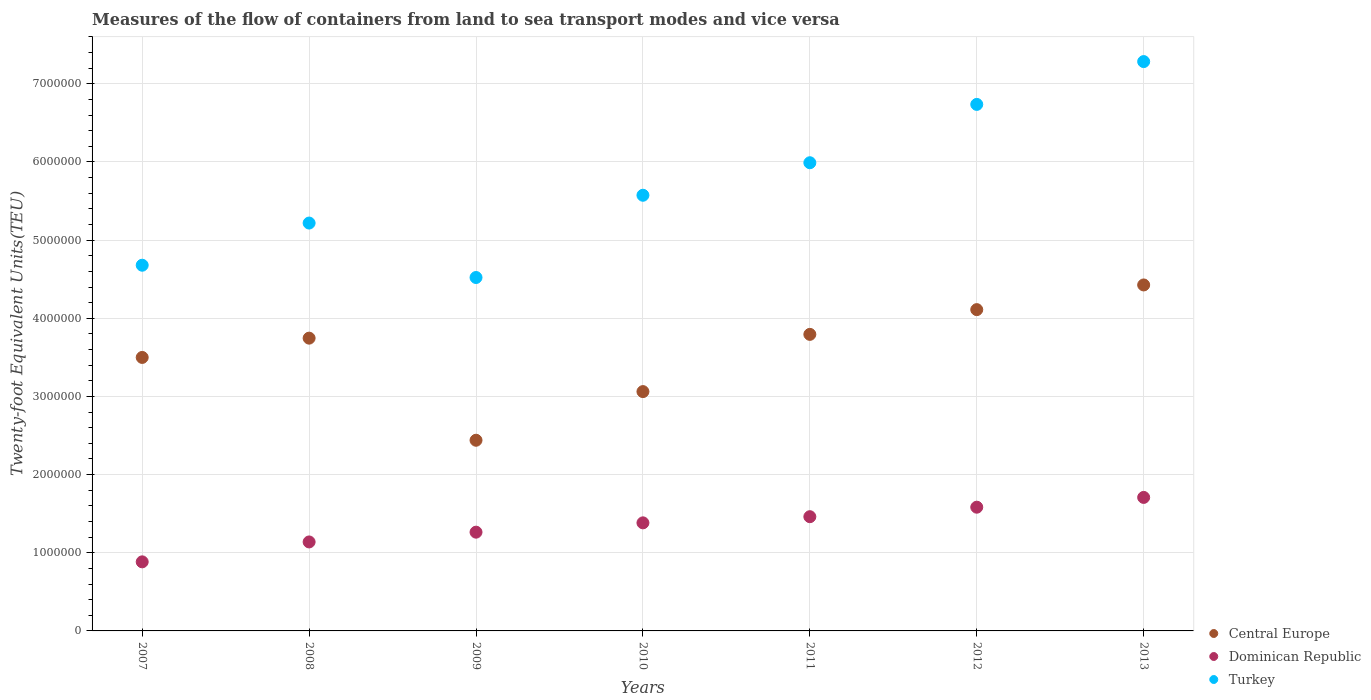How many different coloured dotlines are there?
Ensure brevity in your answer.  3. What is the container port traffic in Turkey in 2009?
Your answer should be very brief. 4.52e+06. Across all years, what is the maximum container port traffic in Dominican Republic?
Your response must be concise. 1.71e+06. Across all years, what is the minimum container port traffic in Turkey?
Ensure brevity in your answer.  4.52e+06. In which year was the container port traffic in Turkey maximum?
Your response must be concise. 2013. In which year was the container port traffic in Turkey minimum?
Your response must be concise. 2009. What is the total container port traffic in Central Europe in the graph?
Make the answer very short. 2.51e+07. What is the difference between the container port traffic in Dominican Republic in 2011 and that in 2012?
Make the answer very short. -1.22e+05. What is the difference between the container port traffic in Central Europe in 2011 and the container port traffic in Dominican Republic in 2008?
Your response must be concise. 2.66e+06. What is the average container port traffic in Central Europe per year?
Provide a succinct answer. 3.58e+06. In the year 2010, what is the difference between the container port traffic in Dominican Republic and container port traffic in Turkey?
Your answer should be very brief. -4.19e+06. In how many years, is the container port traffic in Dominican Republic greater than 1200000 TEU?
Your answer should be compact. 5. What is the ratio of the container port traffic in Turkey in 2011 to that in 2012?
Make the answer very short. 0.89. Is the difference between the container port traffic in Dominican Republic in 2011 and 2013 greater than the difference between the container port traffic in Turkey in 2011 and 2013?
Offer a terse response. Yes. What is the difference between the highest and the second highest container port traffic in Turkey?
Ensure brevity in your answer.  5.48e+05. What is the difference between the highest and the lowest container port traffic in Turkey?
Provide a succinct answer. 2.76e+06. In how many years, is the container port traffic in Dominican Republic greater than the average container port traffic in Dominican Republic taken over all years?
Your answer should be very brief. 4. Is the sum of the container port traffic in Central Europe in 2007 and 2013 greater than the maximum container port traffic in Turkey across all years?
Make the answer very short. Yes. Is it the case that in every year, the sum of the container port traffic in Turkey and container port traffic in Central Europe  is greater than the container port traffic in Dominican Republic?
Your answer should be very brief. Yes. Is the container port traffic in Dominican Republic strictly greater than the container port traffic in Turkey over the years?
Provide a succinct answer. No. Is the container port traffic in Central Europe strictly less than the container port traffic in Turkey over the years?
Provide a short and direct response. Yes. How many dotlines are there?
Make the answer very short. 3. How many years are there in the graph?
Give a very brief answer. 7. Does the graph contain any zero values?
Keep it short and to the point. No. Where does the legend appear in the graph?
Provide a short and direct response. Bottom right. How many legend labels are there?
Your response must be concise. 3. What is the title of the graph?
Offer a very short reply. Measures of the flow of containers from land to sea transport modes and vice versa. What is the label or title of the X-axis?
Offer a terse response. Years. What is the label or title of the Y-axis?
Provide a short and direct response. Twenty-foot Equivalent Units(TEU). What is the Twenty-foot Equivalent Units(TEU) in Central Europe in 2007?
Provide a short and direct response. 3.50e+06. What is the Twenty-foot Equivalent Units(TEU) in Dominican Republic in 2007?
Offer a very short reply. 8.84e+05. What is the Twenty-foot Equivalent Units(TEU) of Turkey in 2007?
Ensure brevity in your answer.  4.68e+06. What is the Twenty-foot Equivalent Units(TEU) in Central Europe in 2008?
Offer a terse response. 3.75e+06. What is the Twenty-foot Equivalent Units(TEU) of Dominican Republic in 2008?
Your answer should be very brief. 1.14e+06. What is the Twenty-foot Equivalent Units(TEU) in Turkey in 2008?
Your response must be concise. 5.22e+06. What is the Twenty-foot Equivalent Units(TEU) in Central Europe in 2009?
Provide a short and direct response. 2.44e+06. What is the Twenty-foot Equivalent Units(TEU) in Dominican Republic in 2009?
Give a very brief answer. 1.26e+06. What is the Twenty-foot Equivalent Units(TEU) of Turkey in 2009?
Offer a very short reply. 4.52e+06. What is the Twenty-foot Equivalent Units(TEU) in Central Europe in 2010?
Keep it short and to the point. 3.06e+06. What is the Twenty-foot Equivalent Units(TEU) in Dominican Republic in 2010?
Provide a succinct answer. 1.38e+06. What is the Twenty-foot Equivalent Units(TEU) in Turkey in 2010?
Make the answer very short. 5.57e+06. What is the Twenty-foot Equivalent Units(TEU) in Central Europe in 2011?
Your answer should be very brief. 3.79e+06. What is the Twenty-foot Equivalent Units(TEU) of Dominican Republic in 2011?
Keep it short and to the point. 1.46e+06. What is the Twenty-foot Equivalent Units(TEU) of Turkey in 2011?
Your answer should be compact. 5.99e+06. What is the Twenty-foot Equivalent Units(TEU) in Central Europe in 2012?
Provide a short and direct response. 4.11e+06. What is the Twenty-foot Equivalent Units(TEU) of Dominican Republic in 2012?
Your answer should be very brief. 1.58e+06. What is the Twenty-foot Equivalent Units(TEU) in Turkey in 2012?
Your answer should be very brief. 6.74e+06. What is the Twenty-foot Equivalent Units(TEU) in Central Europe in 2013?
Your response must be concise. 4.43e+06. What is the Twenty-foot Equivalent Units(TEU) in Dominican Republic in 2013?
Ensure brevity in your answer.  1.71e+06. What is the Twenty-foot Equivalent Units(TEU) in Turkey in 2013?
Provide a short and direct response. 7.28e+06. Across all years, what is the maximum Twenty-foot Equivalent Units(TEU) in Central Europe?
Ensure brevity in your answer.  4.43e+06. Across all years, what is the maximum Twenty-foot Equivalent Units(TEU) in Dominican Republic?
Your answer should be very brief. 1.71e+06. Across all years, what is the maximum Twenty-foot Equivalent Units(TEU) in Turkey?
Offer a terse response. 7.28e+06. Across all years, what is the minimum Twenty-foot Equivalent Units(TEU) of Central Europe?
Your answer should be very brief. 2.44e+06. Across all years, what is the minimum Twenty-foot Equivalent Units(TEU) in Dominican Republic?
Provide a short and direct response. 8.84e+05. Across all years, what is the minimum Twenty-foot Equivalent Units(TEU) in Turkey?
Provide a short and direct response. 4.52e+06. What is the total Twenty-foot Equivalent Units(TEU) of Central Europe in the graph?
Ensure brevity in your answer.  2.51e+07. What is the total Twenty-foot Equivalent Units(TEU) in Dominican Republic in the graph?
Offer a terse response. 9.42e+06. What is the total Twenty-foot Equivalent Units(TEU) of Turkey in the graph?
Provide a short and direct response. 4.00e+07. What is the difference between the Twenty-foot Equivalent Units(TEU) of Central Europe in 2007 and that in 2008?
Your answer should be compact. -2.47e+05. What is the difference between the Twenty-foot Equivalent Units(TEU) of Dominican Republic in 2007 and that in 2008?
Offer a very short reply. -2.55e+05. What is the difference between the Twenty-foot Equivalent Units(TEU) of Turkey in 2007 and that in 2008?
Offer a terse response. -5.39e+05. What is the difference between the Twenty-foot Equivalent Units(TEU) of Central Europe in 2007 and that in 2009?
Offer a very short reply. 1.06e+06. What is the difference between the Twenty-foot Equivalent Units(TEU) in Dominican Republic in 2007 and that in 2009?
Provide a succinct answer. -3.80e+05. What is the difference between the Twenty-foot Equivalent Units(TEU) in Turkey in 2007 and that in 2009?
Provide a short and direct response. 1.57e+05. What is the difference between the Twenty-foot Equivalent Units(TEU) in Central Europe in 2007 and that in 2010?
Provide a short and direct response. 4.37e+05. What is the difference between the Twenty-foot Equivalent Units(TEU) in Dominican Republic in 2007 and that in 2010?
Your response must be concise. -4.99e+05. What is the difference between the Twenty-foot Equivalent Units(TEU) of Turkey in 2007 and that in 2010?
Your response must be concise. -8.95e+05. What is the difference between the Twenty-foot Equivalent Units(TEU) in Central Europe in 2007 and that in 2011?
Give a very brief answer. -2.95e+05. What is the difference between the Twenty-foot Equivalent Units(TEU) of Dominican Republic in 2007 and that in 2011?
Give a very brief answer. -5.78e+05. What is the difference between the Twenty-foot Equivalent Units(TEU) of Turkey in 2007 and that in 2011?
Provide a succinct answer. -1.31e+06. What is the difference between the Twenty-foot Equivalent Units(TEU) in Central Europe in 2007 and that in 2012?
Provide a succinct answer. -6.12e+05. What is the difference between the Twenty-foot Equivalent Units(TEU) in Dominican Republic in 2007 and that in 2012?
Provide a short and direct response. -6.99e+05. What is the difference between the Twenty-foot Equivalent Units(TEU) in Turkey in 2007 and that in 2012?
Ensure brevity in your answer.  -2.06e+06. What is the difference between the Twenty-foot Equivalent Units(TEU) of Central Europe in 2007 and that in 2013?
Give a very brief answer. -9.27e+05. What is the difference between the Twenty-foot Equivalent Units(TEU) of Dominican Republic in 2007 and that in 2013?
Offer a terse response. -8.24e+05. What is the difference between the Twenty-foot Equivalent Units(TEU) in Turkey in 2007 and that in 2013?
Make the answer very short. -2.61e+06. What is the difference between the Twenty-foot Equivalent Units(TEU) in Central Europe in 2008 and that in 2009?
Your answer should be very brief. 1.31e+06. What is the difference between the Twenty-foot Equivalent Units(TEU) in Dominican Republic in 2008 and that in 2009?
Keep it short and to the point. -1.25e+05. What is the difference between the Twenty-foot Equivalent Units(TEU) in Turkey in 2008 and that in 2009?
Offer a very short reply. 6.97e+05. What is the difference between the Twenty-foot Equivalent Units(TEU) of Central Europe in 2008 and that in 2010?
Your answer should be compact. 6.84e+05. What is the difference between the Twenty-foot Equivalent Units(TEU) in Dominican Republic in 2008 and that in 2010?
Provide a succinct answer. -2.44e+05. What is the difference between the Twenty-foot Equivalent Units(TEU) in Turkey in 2008 and that in 2010?
Provide a succinct answer. -3.56e+05. What is the difference between the Twenty-foot Equivalent Units(TEU) of Central Europe in 2008 and that in 2011?
Give a very brief answer. -4.83e+04. What is the difference between the Twenty-foot Equivalent Units(TEU) of Dominican Republic in 2008 and that in 2011?
Offer a very short reply. -3.23e+05. What is the difference between the Twenty-foot Equivalent Units(TEU) of Turkey in 2008 and that in 2011?
Offer a terse response. -7.72e+05. What is the difference between the Twenty-foot Equivalent Units(TEU) in Central Europe in 2008 and that in 2012?
Your answer should be compact. -3.65e+05. What is the difference between the Twenty-foot Equivalent Units(TEU) in Dominican Republic in 2008 and that in 2012?
Give a very brief answer. -4.45e+05. What is the difference between the Twenty-foot Equivalent Units(TEU) in Turkey in 2008 and that in 2012?
Your answer should be compact. -1.52e+06. What is the difference between the Twenty-foot Equivalent Units(TEU) in Central Europe in 2008 and that in 2013?
Ensure brevity in your answer.  -6.81e+05. What is the difference between the Twenty-foot Equivalent Units(TEU) in Dominican Republic in 2008 and that in 2013?
Your answer should be very brief. -5.70e+05. What is the difference between the Twenty-foot Equivalent Units(TEU) of Turkey in 2008 and that in 2013?
Give a very brief answer. -2.07e+06. What is the difference between the Twenty-foot Equivalent Units(TEU) of Central Europe in 2009 and that in 2010?
Give a very brief answer. -6.22e+05. What is the difference between the Twenty-foot Equivalent Units(TEU) in Dominican Republic in 2009 and that in 2010?
Your answer should be very brief. -1.19e+05. What is the difference between the Twenty-foot Equivalent Units(TEU) of Turkey in 2009 and that in 2010?
Your answer should be compact. -1.05e+06. What is the difference between the Twenty-foot Equivalent Units(TEU) of Central Europe in 2009 and that in 2011?
Make the answer very short. -1.35e+06. What is the difference between the Twenty-foot Equivalent Units(TEU) of Dominican Republic in 2009 and that in 2011?
Provide a succinct answer. -1.98e+05. What is the difference between the Twenty-foot Equivalent Units(TEU) in Turkey in 2009 and that in 2011?
Offer a very short reply. -1.47e+06. What is the difference between the Twenty-foot Equivalent Units(TEU) in Central Europe in 2009 and that in 2012?
Your answer should be compact. -1.67e+06. What is the difference between the Twenty-foot Equivalent Units(TEU) of Dominican Republic in 2009 and that in 2012?
Offer a terse response. -3.20e+05. What is the difference between the Twenty-foot Equivalent Units(TEU) in Turkey in 2009 and that in 2012?
Your answer should be compact. -2.21e+06. What is the difference between the Twenty-foot Equivalent Units(TEU) of Central Europe in 2009 and that in 2013?
Provide a succinct answer. -1.99e+06. What is the difference between the Twenty-foot Equivalent Units(TEU) in Dominican Republic in 2009 and that in 2013?
Give a very brief answer. -4.45e+05. What is the difference between the Twenty-foot Equivalent Units(TEU) of Turkey in 2009 and that in 2013?
Give a very brief answer. -2.76e+06. What is the difference between the Twenty-foot Equivalent Units(TEU) of Central Europe in 2010 and that in 2011?
Give a very brief answer. -7.32e+05. What is the difference between the Twenty-foot Equivalent Units(TEU) in Dominican Republic in 2010 and that in 2011?
Ensure brevity in your answer.  -7.88e+04. What is the difference between the Twenty-foot Equivalent Units(TEU) of Turkey in 2010 and that in 2011?
Provide a succinct answer. -4.16e+05. What is the difference between the Twenty-foot Equivalent Units(TEU) of Central Europe in 2010 and that in 2012?
Your answer should be compact. -1.05e+06. What is the difference between the Twenty-foot Equivalent Units(TEU) in Dominican Republic in 2010 and that in 2012?
Your answer should be compact. -2.00e+05. What is the difference between the Twenty-foot Equivalent Units(TEU) of Turkey in 2010 and that in 2012?
Make the answer very short. -1.16e+06. What is the difference between the Twenty-foot Equivalent Units(TEU) of Central Europe in 2010 and that in 2013?
Your answer should be very brief. -1.36e+06. What is the difference between the Twenty-foot Equivalent Units(TEU) of Dominican Republic in 2010 and that in 2013?
Offer a very short reply. -3.25e+05. What is the difference between the Twenty-foot Equivalent Units(TEU) of Turkey in 2010 and that in 2013?
Give a very brief answer. -1.71e+06. What is the difference between the Twenty-foot Equivalent Units(TEU) of Central Europe in 2011 and that in 2012?
Ensure brevity in your answer.  -3.17e+05. What is the difference between the Twenty-foot Equivalent Units(TEU) in Dominican Republic in 2011 and that in 2012?
Provide a succinct answer. -1.22e+05. What is the difference between the Twenty-foot Equivalent Units(TEU) of Turkey in 2011 and that in 2012?
Provide a short and direct response. -7.46e+05. What is the difference between the Twenty-foot Equivalent Units(TEU) in Central Europe in 2011 and that in 2013?
Your answer should be very brief. -6.32e+05. What is the difference between the Twenty-foot Equivalent Units(TEU) of Dominican Republic in 2011 and that in 2013?
Your answer should be very brief. -2.47e+05. What is the difference between the Twenty-foot Equivalent Units(TEU) of Turkey in 2011 and that in 2013?
Make the answer very short. -1.29e+06. What is the difference between the Twenty-foot Equivalent Units(TEU) of Central Europe in 2012 and that in 2013?
Provide a succinct answer. -3.16e+05. What is the difference between the Twenty-foot Equivalent Units(TEU) in Dominican Republic in 2012 and that in 2013?
Your response must be concise. -1.25e+05. What is the difference between the Twenty-foot Equivalent Units(TEU) of Turkey in 2012 and that in 2013?
Provide a short and direct response. -5.48e+05. What is the difference between the Twenty-foot Equivalent Units(TEU) in Central Europe in 2007 and the Twenty-foot Equivalent Units(TEU) in Dominican Republic in 2008?
Offer a very short reply. 2.36e+06. What is the difference between the Twenty-foot Equivalent Units(TEU) in Central Europe in 2007 and the Twenty-foot Equivalent Units(TEU) in Turkey in 2008?
Make the answer very short. -1.72e+06. What is the difference between the Twenty-foot Equivalent Units(TEU) of Dominican Republic in 2007 and the Twenty-foot Equivalent Units(TEU) of Turkey in 2008?
Offer a terse response. -4.33e+06. What is the difference between the Twenty-foot Equivalent Units(TEU) of Central Europe in 2007 and the Twenty-foot Equivalent Units(TEU) of Dominican Republic in 2009?
Provide a short and direct response. 2.24e+06. What is the difference between the Twenty-foot Equivalent Units(TEU) in Central Europe in 2007 and the Twenty-foot Equivalent Units(TEU) in Turkey in 2009?
Give a very brief answer. -1.02e+06. What is the difference between the Twenty-foot Equivalent Units(TEU) of Dominican Republic in 2007 and the Twenty-foot Equivalent Units(TEU) of Turkey in 2009?
Your answer should be compact. -3.64e+06. What is the difference between the Twenty-foot Equivalent Units(TEU) of Central Europe in 2007 and the Twenty-foot Equivalent Units(TEU) of Dominican Republic in 2010?
Offer a very short reply. 2.12e+06. What is the difference between the Twenty-foot Equivalent Units(TEU) in Central Europe in 2007 and the Twenty-foot Equivalent Units(TEU) in Turkey in 2010?
Provide a short and direct response. -2.07e+06. What is the difference between the Twenty-foot Equivalent Units(TEU) in Dominican Republic in 2007 and the Twenty-foot Equivalent Units(TEU) in Turkey in 2010?
Ensure brevity in your answer.  -4.69e+06. What is the difference between the Twenty-foot Equivalent Units(TEU) in Central Europe in 2007 and the Twenty-foot Equivalent Units(TEU) in Dominican Republic in 2011?
Your answer should be compact. 2.04e+06. What is the difference between the Twenty-foot Equivalent Units(TEU) of Central Europe in 2007 and the Twenty-foot Equivalent Units(TEU) of Turkey in 2011?
Offer a very short reply. -2.49e+06. What is the difference between the Twenty-foot Equivalent Units(TEU) of Dominican Republic in 2007 and the Twenty-foot Equivalent Units(TEU) of Turkey in 2011?
Offer a terse response. -5.11e+06. What is the difference between the Twenty-foot Equivalent Units(TEU) of Central Europe in 2007 and the Twenty-foot Equivalent Units(TEU) of Dominican Republic in 2012?
Your answer should be very brief. 1.92e+06. What is the difference between the Twenty-foot Equivalent Units(TEU) in Central Europe in 2007 and the Twenty-foot Equivalent Units(TEU) in Turkey in 2012?
Your response must be concise. -3.24e+06. What is the difference between the Twenty-foot Equivalent Units(TEU) in Dominican Republic in 2007 and the Twenty-foot Equivalent Units(TEU) in Turkey in 2012?
Provide a short and direct response. -5.85e+06. What is the difference between the Twenty-foot Equivalent Units(TEU) of Central Europe in 2007 and the Twenty-foot Equivalent Units(TEU) of Dominican Republic in 2013?
Keep it short and to the point. 1.79e+06. What is the difference between the Twenty-foot Equivalent Units(TEU) in Central Europe in 2007 and the Twenty-foot Equivalent Units(TEU) in Turkey in 2013?
Offer a terse response. -3.79e+06. What is the difference between the Twenty-foot Equivalent Units(TEU) in Dominican Republic in 2007 and the Twenty-foot Equivalent Units(TEU) in Turkey in 2013?
Your answer should be compact. -6.40e+06. What is the difference between the Twenty-foot Equivalent Units(TEU) of Central Europe in 2008 and the Twenty-foot Equivalent Units(TEU) of Dominican Republic in 2009?
Your response must be concise. 2.48e+06. What is the difference between the Twenty-foot Equivalent Units(TEU) in Central Europe in 2008 and the Twenty-foot Equivalent Units(TEU) in Turkey in 2009?
Give a very brief answer. -7.76e+05. What is the difference between the Twenty-foot Equivalent Units(TEU) in Dominican Republic in 2008 and the Twenty-foot Equivalent Units(TEU) in Turkey in 2009?
Provide a short and direct response. -3.38e+06. What is the difference between the Twenty-foot Equivalent Units(TEU) in Central Europe in 2008 and the Twenty-foot Equivalent Units(TEU) in Dominican Republic in 2010?
Offer a terse response. 2.36e+06. What is the difference between the Twenty-foot Equivalent Units(TEU) in Central Europe in 2008 and the Twenty-foot Equivalent Units(TEU) in Turkey in 2010?
Provide a succinct answer. -1.83e+06. What is the difference between the Twenty-foot Equivalent Units(TEU) in Dominican Republic in 2008 and the Twenty-foot Equivalent Units(TEU) in Turkey in 2010?
Offer a terse response. -4.44e+06. What is the difference between the Twenty-foot Equivalent Units(TEU) in Central Europe in 2008 and the Twenty-foot Equivalent Units(TEU) in Dominican Republic in 2011?
Your answer should be very brief. 2.28e+06. What is the difference between the Twenty-foot Equivalent Units(TEU) in Central Europe in 2008 and the Twenty-foot Equivalent Units(TEU) in Turkey in 2011?
Provide a succinct answer. -2.24e+06. What is the difference between the Twenty-foot Equivalent Units(TEU) of Dominican Republic in 2008 and the Twenty-foot Equivalent Units(TEU) of Turkey in 2011?
Provide a succinct answer. -4.85e+06. What is the difference between the Twenty-foot Equivalent Units(TEU) in Central Europe in 2008 and the Twenty-foot Equivalent Units(TEU) in Dominican Republic in 2012?
Your response must be concise. 2.16e+06. What is the difference between the Twenty-foot Equivalent Units(TEU) in Central Europe in 2008 and the Twenty-foot Equivalent Units(TEU) in Turkey in 2012?
Your answer should be very brief. -2.99e+06. What is the difference between the Twenty-foot Equivalent Units(TEU) of Dominican Republic in 2008 and the Twenty-foot Equivalent Units(TEU) of Turkey in 2012?
Your answer should be compact. -5.60e+06. What is the difference between the Twenty-foot Equivalent Units(TEU) of Central Europe in 2008 and the Twenty-foot Equivalent Units(TEU) of Dominican Republic in 2013?
Your answer should be very brief. 2.04e+06. What is the difference between the Twenty-foot Equivalent Units(TEU) in Central Europe in 2008 and the Twenty-foot Equivalent Units(TEU) in Turkey in 2013?
Offer a very short reply. -3.54e+06. What is the difference between the Twenty-foot Equivalent Units(TEU) of Dominican Republic in 2008 and the Twenty-foot Equivalent Units(TEU) of Turkey in 2013?
Offer a very short reply. -6.15e+06. What is the difference between the Twenty-foot Equivalent Units(TEU) of Central Europe in 2009 and the Twenty-foot Equivalent Units(TEU) of Dominican Republic in 2010?
Give a very brief answer. 1.06e+06. What is the difference between the Twenty-foot Equivalent Units(TEU) of Central Europe in 2009 and the Twenty-foot Equivalent Units(TEU) of Turkey in 2010?
Make the answer very short. -3.13e+06. What is the difference between the Twenty-foot Equivalent Units(TEU) of Dominican Republic in 2009 and the Twenty-foot Equivalent Units(TEU) of Turkey in 2010?
Make the answer very short. -4.31e+06. What is the difference between the Twenty-foot Equivalent Units(TEU) of Central Europe in 2009 and the Twenty-foot Equivalent Units(TEU) of Dominican Republic in 2011?
Keep it short and to the point. 9.78e+05. What is the difference between the Twenty-foot Equivalent Units(TEU) in Central Europe in 2009 and the Twenty-foot Equivalent Units(TEU) in Turkey in 2011?
Offer a terse response. -3.55e+06. What is the difference between the Twenty-foot Equivalent Units(TEU) in Dominican Republic in 2009 and the Twenty-foot Equivalent Units(TEU) in Turkey in 2011?
Keep it short and to the point. -4.73e+06. What is the difference between the Twenty-foot Equivalent Units(TEU) of Central Europe in 2009 and the Twenty-foot Equivalent Units(TEU) of Dominican Republic in 2012?
Make the answer very short. 8.56e+05. What is the difference between the Twenty-foot Equivalent Units(TEU) of Central Europe in 2009 and the Twenty-foot Equivalent Units(TEU) of Turkey in 2012?
Your response must be concise. -4.30e+06. What is the difference between the Twenty-foot Equivalent Units(TEU) of Dominican Republic in 2009 and the Twenty-foot Equivalent Units(TEU) of Turkey in 2012?
Your response must be concise. -5.47e+06. What is the difference between the Twenty-foot Equivalent Units(TEU) of Central Europe in 2009 and the Twenty-foot Equivalent Units(TEU) of Dominican Republic in 2013?
Your response must be concise. 7.31e+05. What is the difference between the Twenty-foot Equivalent Units(TEU) of Central Europe in 2009 and the Twenty-foot Equivalent Units(TEU) of Turkey in 2013?
Your response must be concise. -4.84e+06. What is the difference between the Twenty-foot Equivalent Units(TEU) in Dominican Republic in 2009 and the Twenty-foot Equivalent Units(TEU) in Turkey in 2013?
Your response must be concise. -6.02e+06. What is the difference between the Twenty-foot Equivalent Units(TEU) of Central Europe in 2010 and the Twenty-foot Equivalent Units(TEU) of Dominican Republic in 2011?
Offer a terse response. 1.60e+06. What is the difference between the Twenty-foot Equivalent Units(TEU) of Central Europe in 2010 and the Twenty-foot Equivalent Units(TEU) of Turkey in 2011?
Ensure brevity in your answer.  -2.93e+06. What is the difference between the Twenty-foot Equivalent Units(TEU) of Dominican Republic in 2010 and the Twenty-foot Equivalent Units(TEU) of Turkey in 2011?
Your response must be concise. -4.61e+06. What is the difference between the Twenty-foot Equivalent Units(TEU) in Central Europe in 2010 and the Twenty-foot Equivalent Units(TEU) in Dominican Republic in 2012?
Your answer should be very brief. 1.48e+06. What is the difference between the Twenty-foot Equivalent Units(TEU) of Central Europe in 2010 and the Twenty-foot Equivalent Units(TEU) of Turkey in 2012?
Your answer should be compact. -3.67e+06. What is the difference between the Twenty-foot Equivalent Units(TEU) of Dominican Republic in 2010 and the Twenty-foot Equivalent Units(TEU) of Turkey in 2012?
Your answer should be compact. -5.35e+06. What is the difference between the Twenty-foot Equivalent Units(TEU) in Central Europe in 2010 and the Twenty-foot Equivalent Units(TEU) in Dominican Republic in 2013?
Provide a succinct answer. 1.35e+06. What is the difference between the Twenty-foot Equivalent Units(TEU) in Central Europe in 2010 and the Twenty-foot Equivalent Units(TEU) in Turkey in 2013?
Provide a short and direct response. -4.22e+06. What is the difference between the Twenty-foot Equivalent Units(TEU) of Dominican Republic in 2010 and the Twenty-foot Equivalent Units(TEU) of Turkey in 2013?
Provide a succinct answer. -5.90e+06. What is the difference between the Twenty-foot Equivalent Units(TEU) in Central Europe in 2011 and the Twenty-foot Equivalent Units(TEU) in Dominican Republic in 2012?
Keep it short and to the point. 2.21e+06. What is the difference between the Twenty-foot Equivalent Units(TEU) of Central Europe in 2011 and the Twenty-foot Equivalent Units(TEU) of Turkey in 2012?
Keep it short and to the point. -2.94e+06. What is the difference between the Twenty-foot Equivalent Units(TEU) of Dominican Republic in 2011 and the Twenty-foot Equivalent Units(TEU) of Turkey in 2012?
Your answer should be very brief. -5.27e+06. What is the difference between the Twenty-foot Equivalent Units(TEU) of Central Europe in 2011 and the Twenty-foot Equivalent Units(TEU) of Dominican Republic in 2013?
Your response must be concise. 2.09e+06. What is the difference between the Twenty-foot Equivalent Units(TEU) of Central Europe in 2011 and the Twenty-foot Equivalent Units(TEU) of Turkey in 2013?
Your answer should be very brief. -3.49e+06. What is the difference between the Twenty-foot Equivalent Units(TEU) of Dominican Republic in 2011 and the Twenty-foot Equivalent Units(TEU) of Turkey in 2013?
Make the answer very short. -5.82e+06. What is the difference between the Twenty-foot Equivalent Units(TEU) of Central Europe in 2012 and the Twenty-foot Equivalent Units(TEU) of Dominican Republic in 2013?
Provide a succinct answer. 2.40e+06. What is the difference between the Twenty-foot Equivalent Units(TEU) of Central Europe in 2012 and the Twenty-foot Equivalent Units(TEU) of Turkey in 2013?
Your answer should be very brief. -3.17e+06. What is the difference between the Twenty-foot Equivalent Units(TEU) of Dominican Republic in 2012 and the Twenty-foot Equivalent Units(TEU) of Turkey in 2013?
Provide a succinct answer. -5.70e+06. What is the average Twenty-foot Equivalent Units(TEU) of Central Europe per year?
Your response must be concise. 3.58e+06. What is the average Twenty-foot Equivalent Units(TEU) in Dominican Republic per year?
Provide a short and direct response. 1.35e+06. What is the average Twenty-foot Equivalent Units(TEU) of Turkey per year?
Your answer should be very brief. 5.71e+06. In the year 2007, what is the difference between the Twenty-foot Equivalent Units(TEU) in Central Europe and Twenty-foot Equivalent Units(TEU) in Dominican Republic?
Your answer should be very brief. 2.62e+06. In the year 2007, what is the difference between the Twenty-foot Equivalent Units(TEU) in Central Europe and Twenty-foot Equivalent Units(TEU) in Turkey?
Ensure brevity in your answer.  -1.18e+06. In the year 2007, what is the difference between the Twenty-foot Equivalent Units(TEU) of Dominican Republic and Twenty-foot Equivalent Units(TEU) of Turkey?
Make the answer very short. -3.80e+06. In the year 2008, what is the difference between the Twenty-foot Equivalent Units(TEU) of Central Europe and Twenty-foot Equivalent Units(TEU) of Dominican Republic?
Your response must be concise. 2.61e+06. In the year 2008, what is the difference between the Twenty-foot Equivalent Units(TEU) of Central Europe and Twenty-foot Equivalent Units(TEU) of Turkey?
Offer a very short reply. -1.47e+06. In the year 2008, what is the difference between the Twenty-foot Equivalent Units(TEU) in Dominican Republic and Twenty-foot Equivalent Units(TEU) in Turkey?
Provide a short and direct response. -4.08e+06. In the year 2009, what is the difference between the Twenty-foot Equivalent Units(TEU) in Central Europe and Twenty-foot Equivalent Units(TEU) in Dominican Republic?
Your answer should be compact. 1.18e+06. In the year 2009, what is the difference between the Twenty-foot Equivalent Units(TEU) in Central Europe and Twenty-foot Equivalent Units(TEU) in Turkey?
Your response must be concise. -2.08e+06. In the year 2009, what is the difference between the Twenty-foot Equivalent Units(TEU) of Dominican Republic and Twenty-foot Equivalent Units(TEU) of Turkey?
Your response must be concise. -3.26e+06. In the year 2010, what is the difference between the Twenty-foot Equivalent Units(TEU) in Central Europe and Twenty-foot Equivalent Units(TEU) in Dominican Republic?
Your answer should be very brief. 1.68e+06. In the year 2010, what is the difference between the Twenty-foot Equivalent Units(TEU) in Central Europe and Twenty-foot Equivalent Units(TEU) in Turkey?
Provide a succinct answer. -2.51e+06. In the year 2010, what is the difference between the Twenty-foot Equivalent Units(TEU) of Dominican Republic and Twenty-foot Equivalent Units(TEU) of Turkey?
Your response must be concise. -4.19e+06. In the year 2011, what is the difference between the Twenty-foot Equivalent Units(TEU) of Central Europe and Twenty-foot Equivalent Units(TEU) of Dominican Republic?
Your answer should be compact. 2.33e+06. In the year 2011, what is the difference between the Twenty-foot Equivalent Units(TEU) in Central Europe and Twenty-foot Equivalent Units(TEU) in Turkey?
Your response must be concise. -2.20e+06. In the year 2011, what is the difference between the Twenty-foot Equivalent Units(TEU) of Dominican Republic and Twenty-foot Equivalent Units(TEU) of Turkey?
Make the answer very short. -4.53e+06. In the year 2012, what is the difference between the Twenty-foot Equivalent Units(TEU) in Central Europe and Twenty-foot Equivalent Units(TEU) in Dominican Republic?
Ensure brevity in your answer.  2.53e+06. In the year 2012, what is the difference between the Twenty-foot Equivalent Units(TEU) of Central Europe and Twenty-foot Equivalent Units(TEU) of Turkey?
Provide a short and direct response. -2.63e+06. In the year 2012, what is the difference between the Twenty-foot Equivalent Units(TEU) in Dominican Republic and Twenty-foot Equivalent Units(TEU) in Turkey?
Your response must be concise. -5.15e+06. In the year 2013, what is the difference between the Twenty-foot Equivalent Units(TEU) of Central Europe and Twenty-foot Equivalent Units(TEU) of Dominican Republic?
Offer a terse response. 2.72e+06. In the year 2013, what is the difference between the Twenty-foot Equivalent Units(TEU) in Central Europe and Twenty-foot Equivalent Units(TEU) in Turkey?
Provide a short and direct response. -2.86e+06. In the year 2013, what is the difference between the Twenty-foot Equivalent Units(TEU) in Dominican Republic and Twenty-foot Equivalent Units(TEU) in Turkey?
Your answer should be very brief. -5.58e+06. What is the ratio of the Twenty-foot Equivalent Units(TEU) in Central Europe in 2007 to that in 2008?
Provide a short and direct response. 0.93. What is the ratio of the Twenty-foot Equivalent Units(TEU) of Dominican Republic in 2007 to that in 2008?
Make the answer very short. 0.78. What is the ratio of the Twenty-foot Equivalent Units(TEU) in Turkey in 2007 to that in 2008?
Offer a terse response. 0.9. What is the ratio of the Twenty-foot Equivalent Units(TEU) of Central Europe in 2007 to that in 2009?
Provide a succinct answer. 1.43. What is the ratio of the Twenty-foot Equivalent Units(TEU) in Dominican Republic in 2007 to that in 2009?
Offer a very short reply. 0.7. What is the ratio of the Twenty-foot Equivalent Units(TEU) of Turkey in 2007 to that in 2009?
Give a very brief answer. 1.03. What is the ratio of the Twenty-foot Equivalent Units(TEU) of Central Europe in 2007 to that in 2010?
Your answer should be compact. 1.14. What is the ratio of the Twenty-foot Equivalent Units(TEU) in Dominican Republic in 2007 to that in 2010?
Make the answer very short. 0.64. What is the ratio of the Twenty-foot Equivalent Units(TEU) of Turkey in 2007 to that in 2010?
Give a very brief answer. 0.84. What is the ratio of the Twenty-foot Equivalent Units(TEU) of Central Europe in 2007 to that in 2011?
Your response must be concise. 0.92. What is the ratio of the Twenty-foot Equivalent Units(TEU) in Dominican Republic in 2007 to that in 2011?
Offer a very short reply. 0.6. What is the ratio of the Twenty-foot Equivalent Units(TEU) in Turkey in 2007 to that in 2011?
Your response must be concise. 0.78. What is the ratio of the Twenty-foot Equivalent Units(TEU) of Central Europe in 2007 to that in 2012?
Ensure brevity in your answer.  0.85. What is the ratio of the Twenty-foot Equivalent Units(TEU) of Dominican Republic in 2007 to that in 2012?
Keep it short and to the point. 0.56. What is the ratio of the Twenty-foot Equivalent Units(TEU) in Turkey in 2007 to that in 2012?
Keep it short and to the point. 0.69. What is the ratio of the Twenty-foot Equivalent Units(TEU) of Central Europe in 2007 to that in 2013?
Make the answer very short. 0.79. What is the ratio of the Twenty-foot Equivalent Units(TEU) in Dominican Republic in 2007 to that in 2013?
Offer a very short reply. 0.52. What is the ratio of the Twenty-foot Equivalent Units(TEU) in Turkey in 2007 to that in 2013?
Offer a very short reply. 0.64. What is the ratio of the Twenty-foot Equivalent Units(TEU) of Central Europe in 2008 to that in 2009?
Ensure brevity in your answer.  1.54. What is the ratio of the Twenty-foot Equivalent Units(TEU) of Dominican Republic in 2008 to that in 2009?
Your answer should be very brief. 0.9. What is the ratio of the Twenty-foot Equivalent Units(TEU) in Turkey in 2008 to that in 2009?
Give a very brief answer. 1.15. What is the ratio of the Twenty-foot Equivalent Units(TEU) in Central Europe in 2008 to that in 2010?
Make the answer very short. 1.22. What is the ratio of the Twenty-foot Equivalent Units(TEU) in Dominican Republic in 2008 to that in 2010?
Provide a succinct answer. 0.82. What is the ratio of the Twenty-foot Equivalent Units(TEU) in Turkey in 2008 to that in 2010?
Provide a succinct answer. 0.94. What is the ratio of the Twenty-foot Equivalent Units(TEU) in Central Europe in 2008 to that in 2011?
Keep it short and to the point. 0.99. What is the ratio of the Twenty-foot Equivalent Units(TEU) of Dominican Republic in 2008 to that in 2011?
Your answer should be compact. 0.78. What is the ratio of the Twenty-foot Equivalent Units(TEU) in Turkey in 2008 to that in 2011?
Ensure brevity in your answer.  0.87. What is the ratio of the Twenty-foot Equivalent Units(TEU) of Central Europe in 2008 to that in 2012?
Your answer should be compact. 0.91. What is the ratio of the Twenty-foot Equivalent Units(TEU) of Dominican Republic in 2008 to that in 2012?
Offer a terse response. 0.72. What is the ratio of the Twenty-foot Equivalent Units(TEU) of Turkey in 2008 to that in 2012?
Offer a very short reply. 0.77. What is the ratio of the Twenty-foot Equivalent Units(TEU) in Central Europe in 2008 to that in 2013?
Keep it short and to the point. 0.85. What is the ratio of the Twenty-foot Equivalent Units(TEU) in Dominican Republic in 2008 to that in 2013?
Provide a succinct answer. 0.67. What is the ratio of the Twenty-foot Equivalent Units(TEU) of Turkey in 2008 to that in 2013?
Make the answer very short. 0.72. What is the ratio of the Twenty-foot Equivalent Units(TEU) in Central Europe in 2009 to that in 2010?
Make the answer very short. 0.8. What is the ratio of the Twenty-foot Equivalent Units(TEU) of Dominican Republic in 2009 to that in 2010?
Offer a very short reply. 0.91. What is the ratio of the Twenty-foot Equivalent Units(TEU) in Turkey in 2009 to that in 2010?
Ensure brevity in your answer.  0.81. What is the ratio of the Twenty-foot Equivalent Units(TEU) of Central Europe in 2009 to that in 2011?
Your response must be concise. 0.64. What is the ratio of the Twenty-foot Equivalent Units(TEU) in Dominican Republic in 2009 to that in 2011?
Your answer should be compact. 0.86. What is the ratio of the Twenty-foot Equivalent Units(TEU) in Turkey in 2009 to that in 2011?
Your response must be concise. 0.75. What is the ratio of the Twenty-foot Equivalent Units(TEU) of Central Europe in 2009 to that in 2012?
Your answer should be compact. 0.59. What is the ratio of the Twenty-foot Equivalent Units(TEU) in Dominican Republic in 2009 to that in 2012?
Give a very brief answer. 0.8. What is the ratio of the Twenty-foot Equivalent Units(TEU) in Turkey in 2009 to that in 2012?
Keep it short and to the point. 0.67. What is the ratio of the Twenty-foot Equivalent Units(TEU) in Central Europe in 2009 to that in 2013?
Provide a short and direct response. 0.55. What is the ratio of the Twenty-foot Equivalent Units(TEU) of Dominican Republic in 2009 to that in 2013?
Give a very brief answer. 0.74. What is the ratio of the Twenty-foot Equivalent Units(TEU) of Turkey in 2009 to that in 2013?
Provide a succinct answer. 0.62. What is the ratio of the Twenty-foot Equivalent Units(TEU) in Central Europe in 2010 to that in 2011?
Provide a short and direct response. 0.81. What is the ratio of the Twenty-foot Equivalent Units(TEU) in Dominican Republic in 2010 to that in 2011?
Make the answer very short. 0.95. What is the ratio of the Twenty-foot Equivalent Units(TEU) of Turkey in 2010 to that in 2011?
Make the answer very short. 0.93. What is the ratio of the Twenty-foot Equivalent Units(TEU) of Central Europe in 2010 to that in 2012?
Make the answer very short. 0.74. What is the ratio of the Twenty-foot Equivalent Units(TEU) of Dominican Republic in 2010 to that in 2012?
Your answer should be compact. 0.87. What is the ratio of the Twenty-foot Equivalent Units(TEU) of Turkey in 2010 to that in 2012?
Give a very brief answer. 0.83. What is the ratio of the Twenty-foot Equivalent Units(TEU) in Central Europe in 2010 to that in 2013?
Offer a terse response. 0.69. What is the ratio of the Twenty-foot Equivalent Units(TEU) of Dominican Republic in 2010 to that in 2013?
Give a very brief answer. 0.81. What is the ratio of the Twenty-foot Equivalent Units(TEU) of Turkey in 2010 to that in 2013?
Provide a succinct answer. 0.77. What is the ratio of the Twenty-foot Equivalent Units(TEU) of Central Europe in 2011 to that in 2012?
Ensure brevity in your answer.  0.92. What is the ratio of the Twenty-foot Equivalent Units(TEU) in Dominican Republic in 2011 to that in 2012?
Your answer should be very brief. 0.92. What is the ratio of the Twenty-foot Equivalent Units(TEU) in Turkey in 2011 to that in 2012?
Keep it short and to the point. 0.89. What is the ratio of the Twenty-foot Equivalent Units(TEU) of Central Europe in 2011 to that in 2013?
Make the answer very short. 0.86. What is the ratio of the Twenty-foot Equivalent Units(TEU) in Dominican Republic in 2011 to that in 2013?
Make the answer very short. 0.86. What is the ratio of the Twenty-foot Equivalent Units(TEU) in Turkey in 2011 to that in 2013?
Ensure brevity in your answer.  0.82. What is the ratio of the Twenty-foot Equivalent Units(TEU) in Central Europe in 2012 to that in 2013?
Your response must be concise. 0.93. What is the ratio of the Twenty-foot Equivalent Units(TEU) of Dominican Republic in 2012 to that in 2013?
Give a very brief answer. 0.93. What is the ratio of the Twenty-foot Equivalent Units(TEU) of Turkey in 2012 to that in 2013?
Give a very brief answer. 0.92. What is the difference between the highest and the second highest Twenty-foot Equivalent Units(TEU) in Central Europe?
Provide a succinct answer. 3.16e+05. What is the difference between the highest and the second highest Twenty-foot Equivalent Units(TEU) in Dominican Republic?
Give a very brief answer. 1.25e+05. What is the difference between the highest and the second highest Twenty-foot Equivalent Units(TEU) in Turkey?
Give a very brief answer. 5.48e+05. What is the difference between the highest and the lowest Twenty-foot Equivalent Units(TEU) of Central Europe?
Provide a succinct answer. 1.99e+06. What is the difference between the highest and the lowest Twenty-foot Equivalent Units(TEU) of Dominican Republic?
Your answer should be very brief. 8.24e+05. What is the difference between the highest and the lowest Twenty-foot Equivalent Units(TEU) of Turkey?
Offer a very short reply. 2.76e+06. 